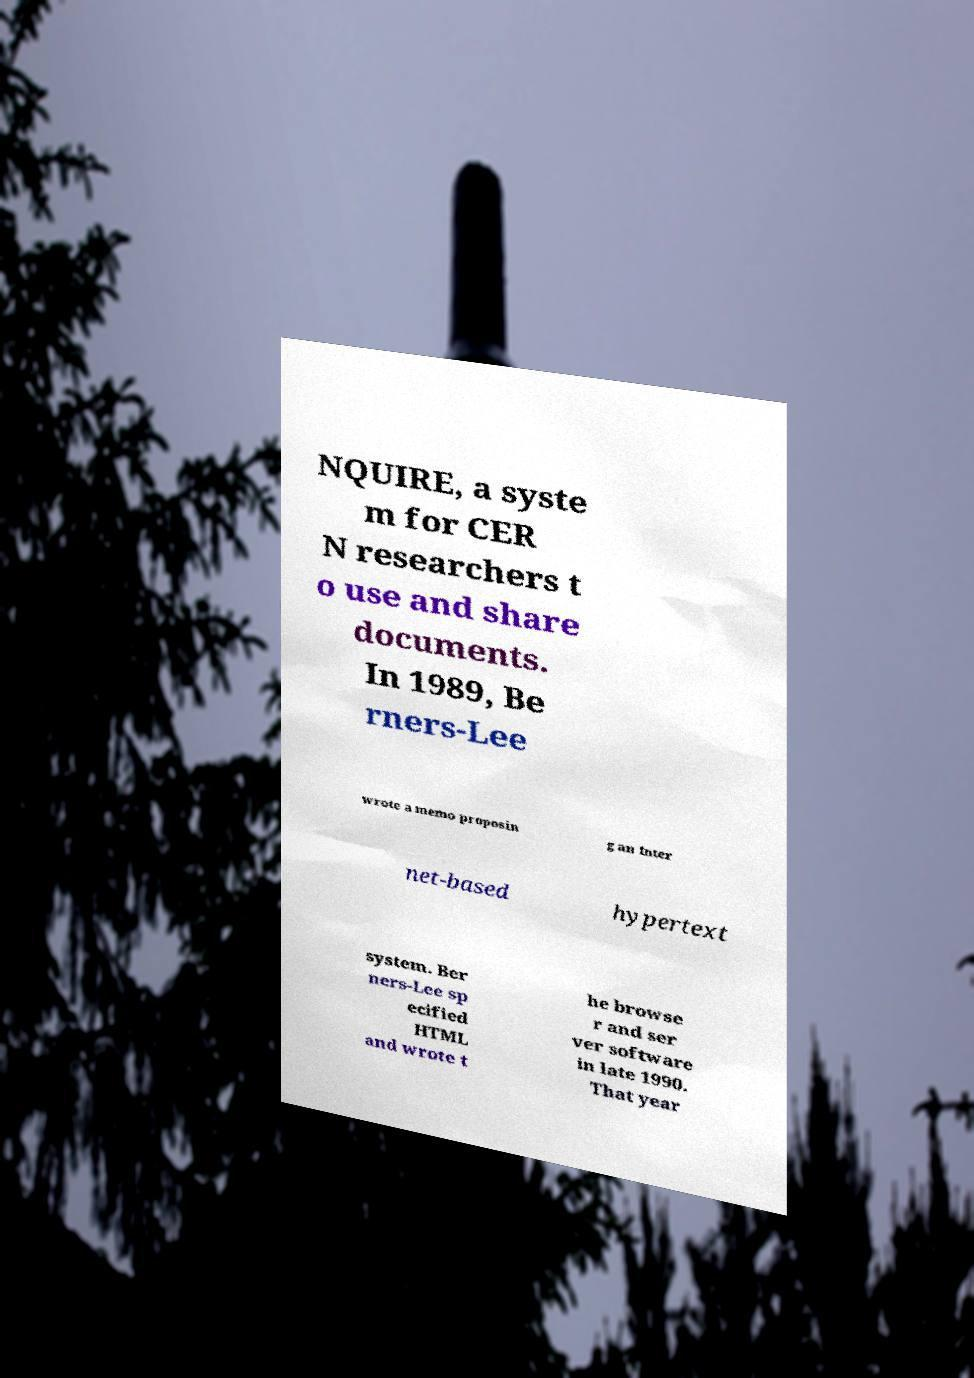Can you read and provide the text displayed in the image?This photo seems to have some interesting text. Can you extract and type it out for me? NQUIRE, a syste m for CER N researchers t o use and share documents. In 1989, Be rners-Lee wrote a memo proposin g an Inter net-based hypertext system. Ber ners-Lee sp ecified HTML and wrote t he browse r and ser ver software in late 1990. That year 